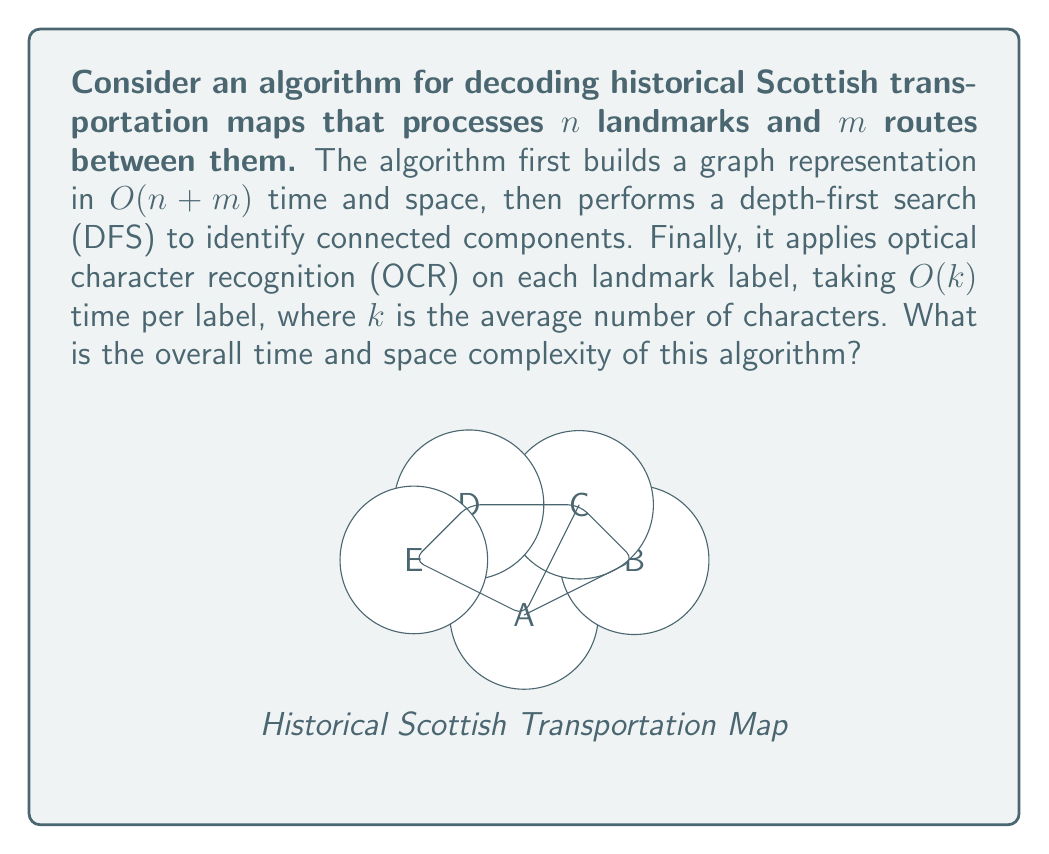Teach me how to tackle this problem. Let's break down the algorithm's complexity step by step:

1. Graph Construction:
   - Time complexity: $O(n + m)$
   - Space complexity: $O(n + m)$
   This step creates the graph representation with $n$ vertices and $m$ edges.

2. Depth-First Search (DFS):
   - Time complexity: $O(n + m)$
   - Space complexity: $O(n)$ for the recursion stack
   DFS visits each vertex and edge once, taking linear time in the size of the graph.

3. Optical Character Recognition (OCR):
   - Time complexity: $O(nk)$, where $k$ is the average number of characters per label
   - Space complexity: $O(k)$ for processing each label
   OCR is applied to each of the $n$ landmarks, taking $O(k)$ time per label.

Overall Time Complexity:
$$T(n, m, k) = O(n + m) + O(n + m) + O(nk) = O(n + m + nk)$$

The dominant term depends on the relative sizes of $m$ and $nk$. In the worst case, where $m \approx n^2$ (fully connected graph), the time complexity would be $O(n^2 + nk)$.

Overall Space Complexity:
$$S(n, m, k) = O(n + m) + O(n) + O(k) = O(n + m)$$

The graph representation dominates the space complexity, as it needs to store all vertices and edges.
Answer: Time: $O(n^2 + nk)$, Space: $O(n + m)$ 